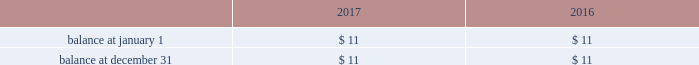Host hotels & resorts , inc. , host hotels & resorts , l.p. , and subsidiaries notes to consolidated financial statements 2014 ( continued ) cash paid for income taxes , net of refunds received , was $ 40 million , $ 15 million , and $ 9 million in 2017 , 2016 , and 2015 , respectively .
A reconciliation of the beginning and ending amount of unrecognized tax benefits is as follows ( in millions ) : .
All of such uncertain tax position amounts , if recognized , would impact our reconciliation between the income tax provision calculated at the statutory u.s .
Federal income tax rate of 35% ( 35 % ) ( 21% ( 21 % ) beginning with calendar year 2018 ) and the actual income tax provision recorded each year .
As of december 31 , 2017 , the tax years that remain subject to examination by major tax jurisdictions generally include 2014-2017 .
There were no material interest or penalties recorded for the years ended december 31 , 2017 , 2016 , and 2015 .
Leases taxable reit subsidiaries leases we lease substantially all of our hotels to a wholly owned subsidiary that qualifies as a taxable reit subsidiary due to federal income tax restrictions on a reit 2019s ability to derive revenue directly from the operation and management of a hotel .
Ground leases as of december 31 , 2017 , all or a portion of 26 of our hotels are subject to ground leases , generally with multiple renewal options , all of which are accounted for as operating leases .
For lease agreements with scheduled rent increases , we recognize the lease expense ratably over the term of the lease .
Certain of these leases contain provisions for the payment of contingent rentals based on a percentage of sales in excess of stipulated amounts .
Other lease information we also have leases on facilities used in our former restaurant business , all of which we subsequently subleased .
These leases and subleases contain one or more renewal options , generally for five- or ten-year periods .
The restaurant leases are accounted for as operating leases .
Our contingent liability related to these leases is $ 9 million as of december 31 , 2017 .
We , however , consider the likelihood of any material funding related to these leases to be remote .
Our leasing activity also includes those entered into by our hotels for various types of equipment , such as computer equipment , vehicles and telephone systems .
Equipment leases are accounted for either as operating or capital leases , depending upon the characteristics of the particular lease arrangement .
Equipment leases that are characterized as capital leases are classified as furniture and equipment and are depreciated over the life of the lease .
The amortization expense applicable to capitalized leases is included in depreciation expense. .
What was the percentage change in cash paid for income taxes , net of refunds received between 2016 and 2017? 
Computations: ((40 - 15) / 15)
Answer: 1.66667. 